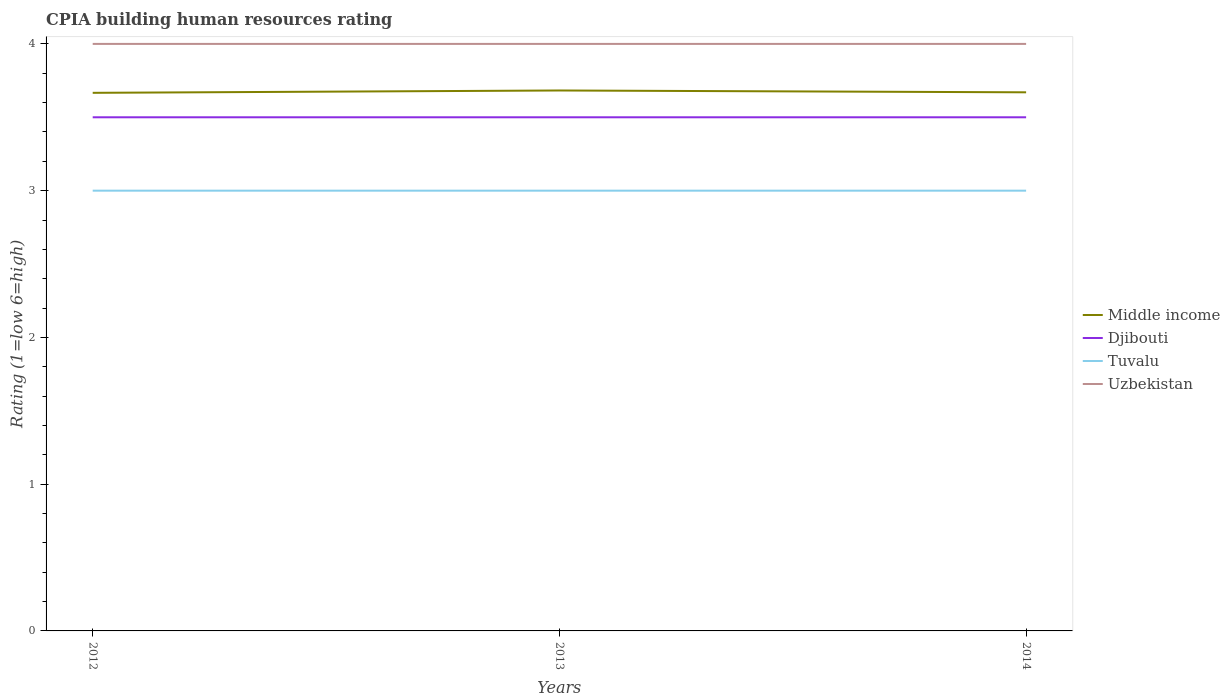How many different coloured lines are there?
Make the answer very short. 4. Does the line corresponding to Middle income intersect with the line corresponding to Djibouti?
Make the answer very short. No. Across all years, what is the maximum CPIA rating in Tuvalu?
Give a very brief answer. 3. What is the total CPIA rating in Djibouti in the graph?
Give a very brief answer. 0. What is the difference between the highest and the second highest CPIA rating in Middle income?
Keep it short and to the point. 0.02. What is the difference between the highest and the lowest CPIA rating in Tuvalu?
Give a very brief answer. 0. Is the CPIA rating in Djibouti strictly greater than the CPIA rating in Tuvalu over the years?
Keep it short and to the point. No. Are the values on the major ticks of Y-axis written in scientific E-notation?
Your response must be concise. No. Does the graph contain any zero values?
Provide a succinct answer. No. Where does the legend appear in the graph?
Keep it short and to the point. Center right. How many legend labels are there?
Your answer should be compact. 4. What is the title of the graph?
Give a very brief answer. CPIA building human resources rating. Does "Algeria" appear as one of the legend labels in the graph?
Give a very brief answer. No. What is the label or title of the X-axis?
Keep it short and to the point. Years. What is the Rating (1=low 6=high) in Middle income in 2012?
Provide a succinct answer. 3.67. What is the Rating (1=low 6=high) in Uzbekistan in 2012?
Ensure brevity in your answer.  4. What is the Rating (1=low 6=high) in Middle income in 2013?
Provide a short and direct response. 3.68. What is the Rating (1=low 6=high) in Djibouti in 2013?
Provide a succinct answer. 3.5. What is the Rating (1=low 6=high) in Tuvalu in 2013?
Offer a very short reply. 3. What is the Rating (1=low 6=high) in Uzbekistan in 2013?
Your answer should be compact. 4. What is the Rating (1=low 6=high) of Middle income in 2014?
Your answer should be very brief. 3.67. What is the Rating (1=low 6=high) of Tuvalu in 2014?
Ensure brevity in your answer.  3. What is the Rating (1=low 6=high) of Uzbekistan in 2014?
Offer a very short reply. 4. Across all years, what is the maximum Rating (1=low 6=high) in Middle income?
Make the answer very short. 3.68. Across all years, what is the maximum Rating (1=low 6=high) in Djibouti?
Give a very brief answer. 3.5. Across all years, what is the minimum Rating (1=low 6=high) of Middle income?
Offer a terse response. 3.67. Across all years, what is the minimum Rating (1=low 6=high) in Djibouti?
Your answer should be compact. 3.5. Across all years, what is the minimum Rating (1=low 6=high) of Tuvalu?
Give a very brief answer. 3. What is the total Rating (1=low 6=high) of Middle income in the graph?
Give a very brief answer. 11.02. What is the total Rating (1=low 6=high) of Djibouti in the graph?
Give a very brief answer. 10.5. What is the total Rating (1=low 6=high) in Tuvalu in the graph?
Keep it short and to the point. 9. What is the difference between the Rating (1=low 6=high) in Middle income in 2012 and that in 2013?
Provide a short and direct response. -0.02. What is the difference between the Rating (1=low 6=high) of Tuvalu in 2012 and that in 2013?
Make the answer very short. 0. What is the difference between the Rating (1=low 6=high) in Uzbekistan in 2012 and that in 2013?
Offer a terse response. 0. What is the difference between the Rating (1=low 6=high) in Middle income in 2012 and that in 2014?
Your answer should be very brief. -0. What is the difference between the Rating (1=low 6=high) in Middle income in 2013 and that in 2014?
Provide a short and direct response. 0.01. What is the difference between the Rating (1=low 6=high) in Middle income in 2012 and the Rating (1=low 6=high) in Djibouti in 2013?
Your answer should be very brief. 0.17. What is the difference between the Rating (1=low 6=high) of Middle income in 2012 and the Rating (1=low 6=high) of Uzbekistan in 2013?
Ensure brevity in your answer.  -0.33. What is the difference between the Rating (1=low 6=high) in Djibouti in 2012 and the Rating (1=low 6=high) in Tuvalu in 2013?
Your response must be concise. 0.5. What is the difference between the Rating (1=low 6=high) of Middle income in 2012 and the Rating (1=low 6=high) of Djibouti in 2014?
Provide a short and direct response. 0.17. What is the difference between the Rating (1=low 6=high) of Middle income in 2012 and the Rating (1=low 6=high) of Tuvalu in 2014?
Make the answer very short. 0.67. What is the difference between the Rating (1=low 6=high) of Djibouti in 2012 and the Rating (1=low 6=high) of Tuvalu in 2014?
Make the answer very short. 0.5. What is the difference between the Rating (1=low 6=high) in Djibouti in 2012 and the Rating (1=low 6=high) in Uzbekistan in 2014?
Make the answer very short. -0.5. What is the difference between the Rating (1=low 6=high) of Middle income in 2013 and the Rating (1=low 6=high) of Djibouti in 2014?
Make the answer very short. 0.18. What is the difference between the Rating (1=low 6=high) in Middle income in 2013 and the Rating (1=low 6=high) in Tuvalu in 2014?
Make the answer very short. 0.68. What is the difference between the Rating (1=low 6=high) of Middle income in 2013 and the Rating (1=low 6=high) of Uzbekistan in 2014?
Keep it short and to the point. -0.32. What is the average Rating (1=low 6=high) of Middle income per year?
Provide a succinct answer. 3.67. What is the average Rating (1=low 6=high) of Tuvalu per year?
Make the answer very short. 3. What is the average Rating (1=low 6=high) of Uzbekistan per year?
Keep it short and to the point. 4. In the year 2012, what is the difference between the Rating (1=low 6=high) in Middle income and Rating (1=low 6=high) in Djibouti?
Keep it short and to the point. 0.17. In the year 2012, what is the difference between the Rating (1=low 6=high) in Middle income and Rating (1=low 6=high) in Tuvalu?
Keep it short and to the point. 0.67. In the year 2012, what is the difference between the Rating (1=low 6=high) in Middle income and Rating (1=low 6=high) in Uzbekistan?
Offer a very short reply. -0.33. In the year 2012, what is the difference between the Rating (1=low 6=high) in Djibouti and Rating (1=low 6=high) in Tuvalu?
Your answer should be very brief. 0.5. In the year 2012, what is the difference between the Rating (1=low 6=high) of Djibouti and Rating (1=low 6=high) of Uzbekistan?
Make the answer very short. -0.5. In the year 2013, what is the difference between the Rating (1=low 6=high) in Middle income and Rating (1=low 6=high) in Djibouti?
Offer a terse response. 0.18. In the year 2013, what is the difference between the Rating (1=low 6=high) in Middle income and Rating (1=low 6=high) in Tuvalu?
Offer a terse response. 0.68. In the year 2013, what is the difference between the Rating (1=low 6=high) of Middle income and Rating (1=low 6=high) of Uzbekistan?
Your response must be concise. -0.32. In the year 2014, what is the difference between the Rating (1=low 6=high) of Middle income and Rating (1=low 6=high) of Djibouti?
Your response must be concise. 0.17. In the year 2014, what is the difference between the Rating (1=low 6=high) in Middle income and Rating (1=low 6=high) in Tuvalu?
Make the answer very short. 0.67. In the year 2014, what is the difference between the Rating (1=low 6=high) of Middle income and Rating (1=low 6=high) of Uzbekistan?
Your response must be concise. -0.33. In the year 2014, what is the difference between the Rating (1=low 6=high) of Tuvalu and Rating (1=low 6=high) of Uzbekistan?
Keep it short and to the point. -1. What is the ratio of the Rating (1=low 6=high) of Tuvalu in 2012 to that in 2013?
Ensure brevity in your answer.  1. What is the ratio of the Rating (1=low 6=high) of Uzbekistan in 2012 to that in 2013?
Offer a terse response. 1. What is the ratio of the Rating (1=low 6=high) of Djibouti in 2012 to that in 2014?
Your answer should be very brief. 1. What is the ratio of the Rating (1=low 6=high) of Uzbekistan in 2012 to that in 2014?
Provide a succinct answer. 1. What is the ratio of the Rating (1=low 6=high) of Tuvalu in 2013 to that in 2014?
Give a very brief answer. 1. What is the ratio of the Rating (1=low 6=high) in Uzbekistan in 2013 to that in 2014?
Your answer should be very brief. 1. What is the difference between the highest and the second highest Rating (1=low 6=high) in Middle income?
Keep it short and to the point. 0.01. What is the difference between the highest and the second highest Rating (1=low 6=high) of Djibouti?
Offer a very short reply. 0. What is the difference between the highest and the second highest Rating (1=low 6=high) in Tuvalu?
Give a very brief answer. 0. What is the difference between the highest and the lowest Rating (1=low 6=high) in Middle income?
Make the answer very short. 0.02. What is the difference between the highest and the lowest Rating (1=low 6=high) in Djibouti?
Give a very brief answer. 0. What is the difference between the highest and the lowest Rating (1=low 6=high) in Tuvalu?
Your response must be concise. 0. 